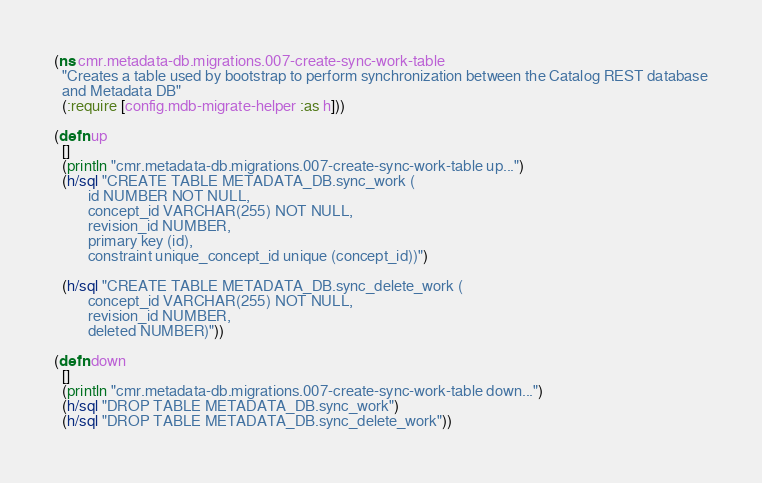<code> <loc_0><loc_0><loc_500><loc_500><_Clojure_>(ns cmr.metadata-db.migrations.007-create-sync-work-table
  "Creates a table used by bootstrap to perform synchronization between the Catalog REST database
  and Metadata DB"
  (:require [config.mdb-migrate-helper :as h]))

(defn up
  []
  (println "cmr.metadata-db.migrations.007-create-sync-work-table up...")
  (h/sql "CREATE TABLE METADATA_DB.sync_work (
         id NUMBER NOT NULL,
         concept_id VARCHAR(255) NOT NULL,
         revision_id NUMBER,
         primary key (id),
         constraint unique_concept_id unique (concept_id))")

  (h/sql "CREATE TABLE METADATA_DB.sync_delete_work (
         concept_id VARCHAR(255) NOT NULL,
         revision_id NUMBER,
         deleted NUMBER)"))

(defn down
  []
  (println "cmr.metadata-db.migrations.007-create-sync-work-table down...")
  (h/sql "DROP TABLE METADATA_DB.sync_work")
  (h/sql "DROP TABLE METADATA_DB.sync_delete_work"))</code> 